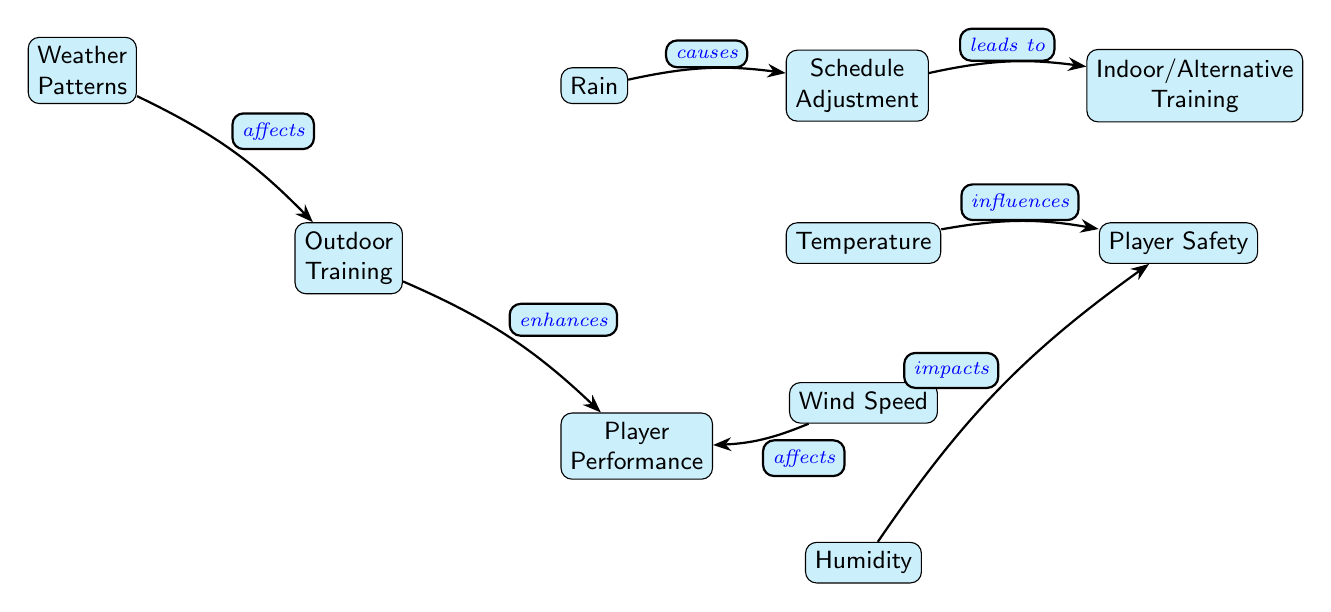What is the main subject of the diagram? The diagram’s title is "Weather Patterns", indicating that the main subject revolves around various weather factors.
Answer: Weather Patterns Which node directly influences Player Safety? The only node that has a direct influence on Player Safety is Temperature, as seen from the arrow pointing to Player Safety from Temperature.
Answer: Temperature How many nodes are in the diagram? Counting all distinct nodes, there are a total of 8 nodes presented in the diagram.
Answer: 8 What relationship exists between Rain and Schedule Adjustment? The diagram shows that Rain causes Schedule Adjustment, as indicated by the arrow from Rain to Schedule Adjustment labeled "causes."
Answer: causes What leads to Indoor/Alternative Training? The diagram shows that Schedule Adjustment leads to Indoor/Alternative Training, which can be tracked by following the path of the arrows.
Answer: leads to Which weather factor affects Player Performance? Wind Speed directly affects Player Performance, indicated by the arrow pointing from Wind Speed to Player Performance in the diagram.
Answer: Wind Speed What is the connection between Humidity and Player Safety? The diagram indicates that Humidity impacts Player Safety, as denoted by the edge labeled "impacts" flowing from Humidity to Player Safety.
Answer: impacts What is the final outcome of Outdoor Training according to the diagram? Outdoor Training enhances Player Performance as per the directed edge in the diagram from Outdoor Training to Player Performance labeled "enhances."
Answer: enhances Which factor is shown to cause Schedule Adjustment? Rain is indicated as the factor that causes Schedule Adjustment, as evidenced by the direct connection in the diagram.
Answer: causes 